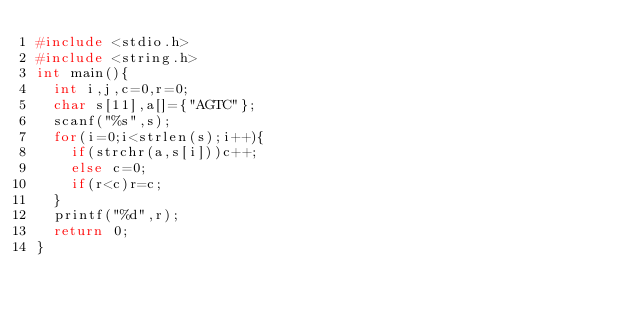Convert code to text. <code><loc_0><loc_0><loc_500><loc_500><_C_>#include <stdio.h>
#include <string.h>
int main(){
  int i,j,c=0,r=0;
  char s[11],a[]={"AGTC"};
  scanf("%s",s);
  for(i=0;i<strlen(s);i++){
    if(strchr(a,s[i]))c++;
    else c=0;
    if(r<c)r=c;
  }
  printf("%d",r);
  return 0;
}</code> 